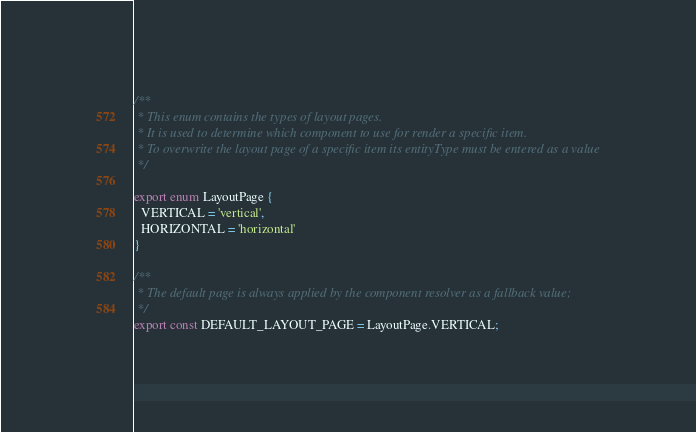<code> <loc_0><loc_0><loc_500><loc_500><_TypeScript_>/**
 * This enum contains the types of layout pages.
 * It is used to determine which component to use for render a specific item.
 * To overwrite the layout page of a specific item its entityType must be entered as a value
 */

export enum LayoutPage {
  VERTICAL = 'vertical',
  HORIZONTAL = 'horizontal'
}

/**
 * The default page is always applied by the component resolver as a fallback value;
 */
export const DEFAULT_LAYOUT_PAGE = LayoutPage.VERTICAL;
</code> 